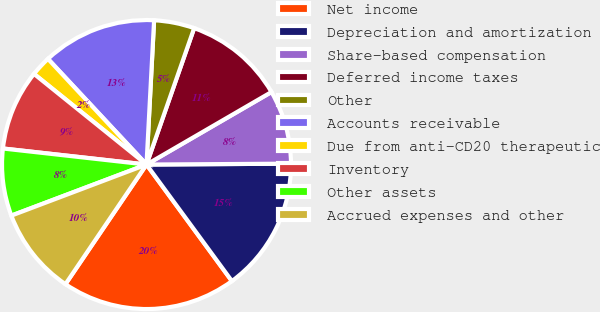<chart> <loc_0><loc_0><loc_500><loc_500><pie_chart><fcel>Net income<fcel>Depreciation and amortization<fcel>Share-based compensation<fcel>Deferred income taxes<fcel>Other<fcel>Accounts receivable<fcel>Due from anti-CD20 therapeutic<fcel>Inventory<fcel>Other assets<fcel>Accrued expenses and other<nl><fcel>19.54%<fcel>15.03%<fcel>8.27%<fcel>11.28%<fcel>4.51%<fcel>12.78%<fcel>2.26%<fcel>9.02%<fcel>7.52%<fcel>9.77%<nl></chart> 